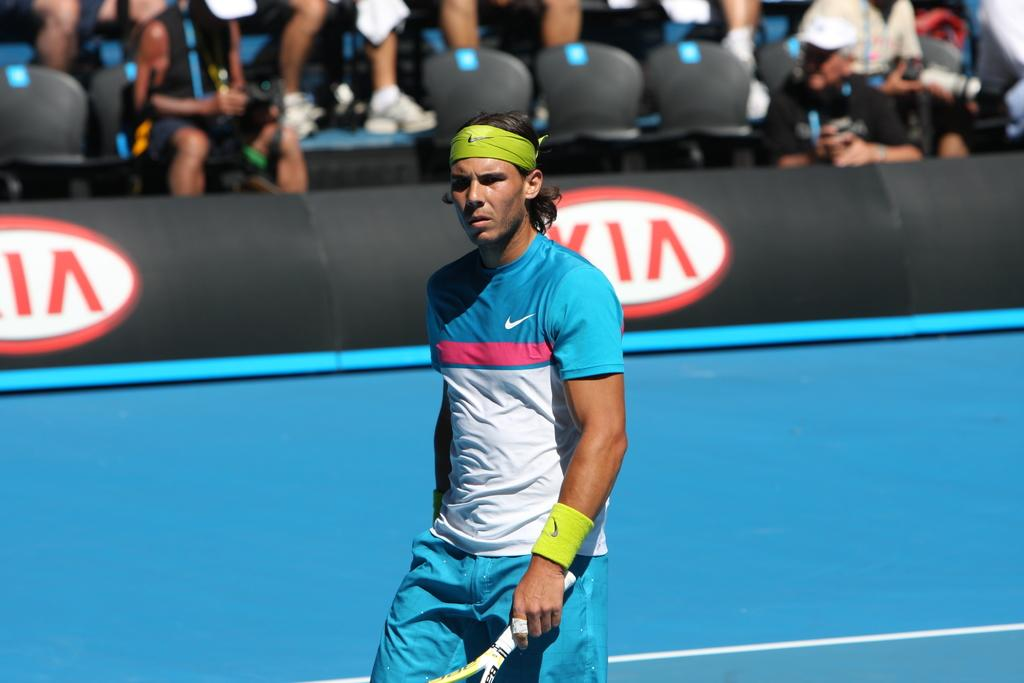What is the main subject of the image? There is a man in the image. What is the man holding in his hand? The man is holding a racket with his hand. Can you describe the setting in the background of the image? There are people sitting on chairs in the background of the image. What type of wrench is the man using to hit the ball in the image? There is no wrench present in the image; the man is holding a racket. How many bikes can be seen in the image? There are no bikes visible in the image. 